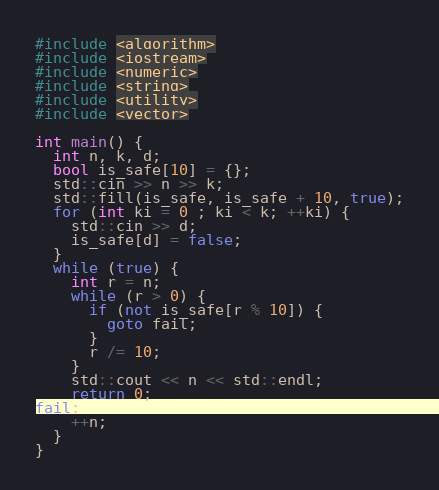<code> <loc_0><loc_0><loc_500><loc_500><_C++_>#include <algorithm>
#include <iostream>
#include <numeric>
#include <string>
#include <utility>
#include <vector>

int main() {
  int n, k, d;
  bool is_safe[10] = {};
  std::cin >> n >> k;
  std::fill(is_safe, is_safe + 10, true);
  for (int ki = 0 ; ki < k; ++ki) {
    std::cin >> d;
    is_safe[d] = false;
  }
  while (true) {
    int r = n;
    while (r > 0) {
      if (not is_safe[r % 10]) {
        goto fail;
      }
      r /= 10;
    }
    std::cout << n << std::endl;
    return 0;
fail:
    ++n;
  }
}</code> 